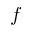<formula> <loc_0><loc_0><loc_500><loc_500>f</formula> 